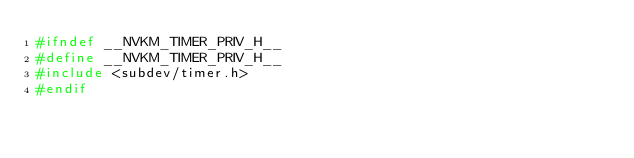<code> <loc_0><loc_0><loc_500><loc_500><_C_>#ifndef __NVKM_TIMER_PRIV_H__
#define __NVKM_TIMER_PRIV_H__
#include <subdev/timer.h>
#endif
</code> 